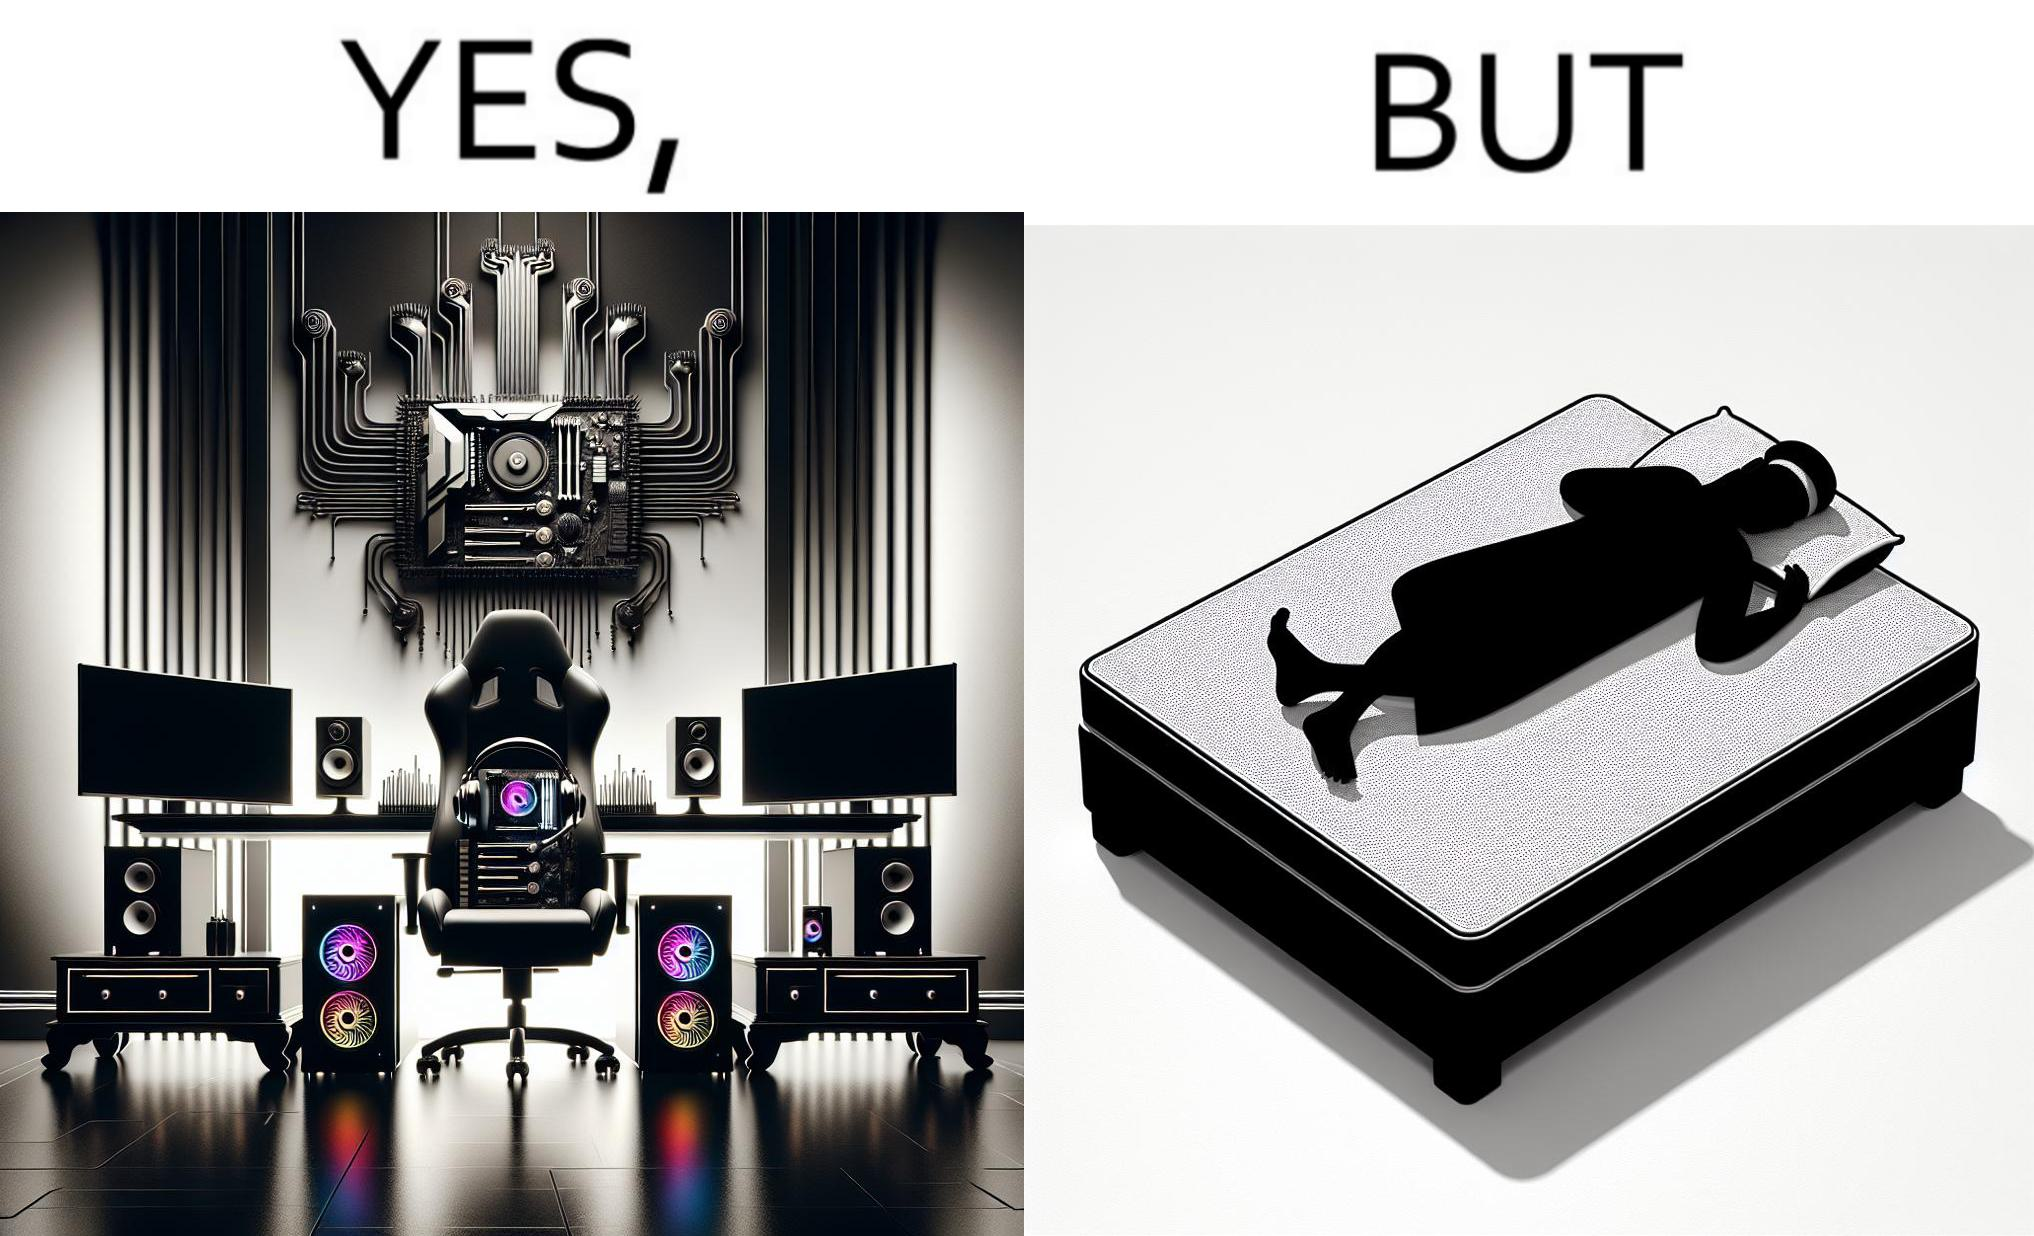What does this image depict? The image is funny because the person has a lot of furniture for his computer but none for himself. 